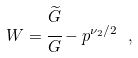Convert formula to latex. <formula><loc_0><loc_0><loc_500><loc_500>W = \cfrac { \widetilde { G } } { G } - p ^ { \nu _ { 2 } / 2 } \ ,</formula> 